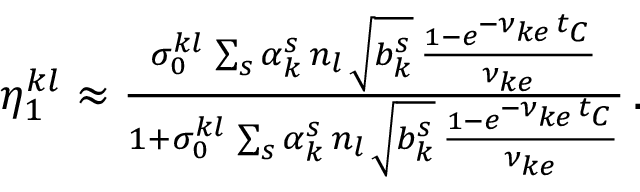<formula> <loc_0><loc_0><loc_500><loc_500>\begin{array} { r l r } & { \eta _ { 1 } ^ { k l } \approx \frac { \sigma _ { 0 } ^ { k l } \, \sum _ { s } \alpha _ { k } ^ { s } \, n _ { l } \, \sqrt { b _ { k } ^ { s } } \, \frac { 1 - e ^ { - \nu _ { k e } \, t _ { C } } } { \nu _ { k e } } } { 1 + \sigma _ { 0 } ^ { k l } \, \sum _ { s } \alpha _ { k } ^ { s } \, n _ { l } \, \sqrt { b _ { k } ^ { s } } \, \frac { 1 - e ^ { - \nu _ { k e } \, t _ { C } } } { \nu _ { k e } } } \, . } \end{array}</formula> 